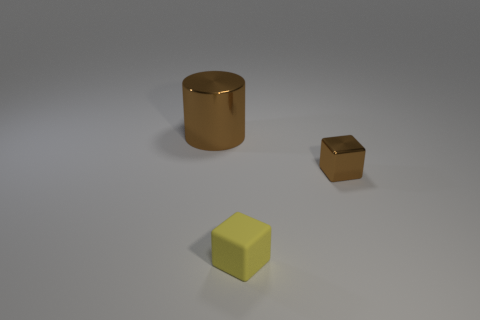Is the color of the big metallic object the same as the metallic thing in front of the large brown metallic object?
Provide a succinct answer. Yes. There is a metal object left of the tiny shiny thing; does it have the same color as the small metallic cube in front of the brown metallic cylinder?
Offer a very short reply. Yes. Is the number of tiny brown things greater than the number of metallic objects?
Provide a short and direct response. No. Is the small yellow object the same shape as the small brown metallic thing?
Your answer should be very brief. Yes. What material is the tiny cube behind the tiny block left of the brown shiny block?
Offer a terse response. Metal. There is a cylinder that is the same color as the shiny cube; what material is it?
Give a very brief answer. Metal. Is the brown metal cylinder the same size as the brown shiny block?
Your answer should be very brief. No. There is a small object to the right of the yellow rubber cube; are there any brown metal objects on the left side of it?
Offer a terse response. Yes. The shiny cylinder that is the same color as the metallic cube is what size?
Your answer should be compact. Large. What is the shape of the metal object that is left of the yellow object?
Ensure brevity in your answer.  Cylinder. 